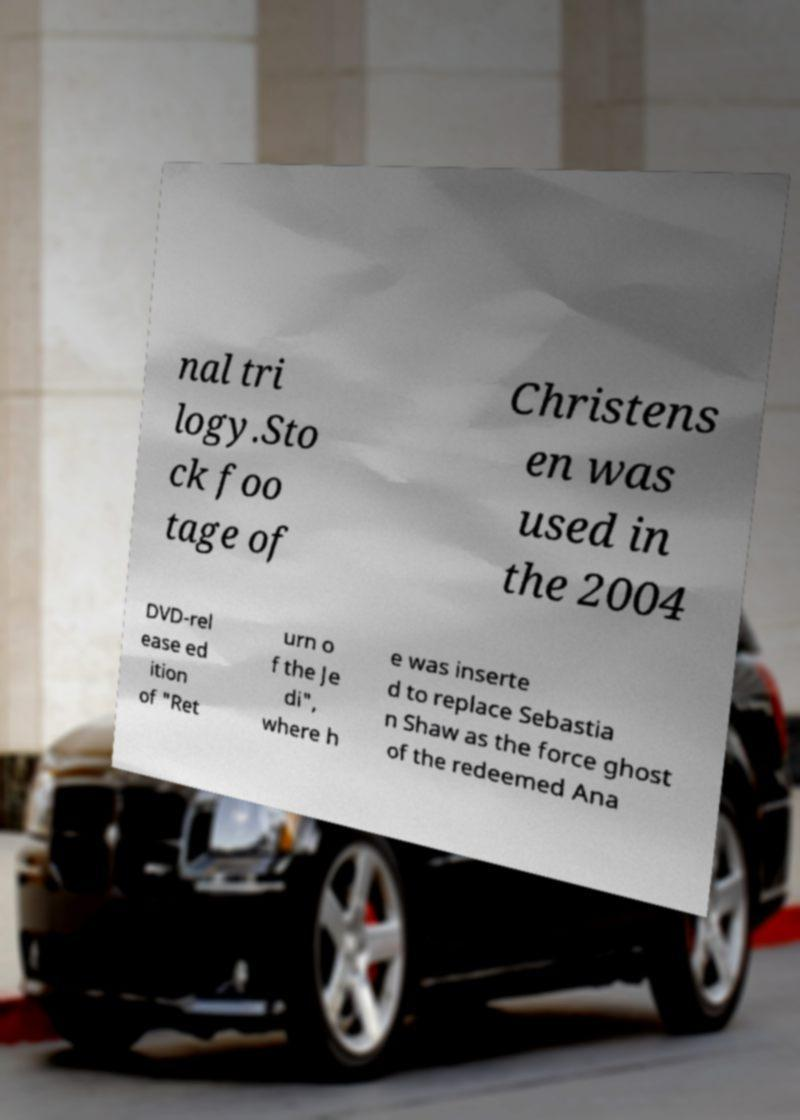Could you extract and type out the text from this image? nal tri logy.Sto ck foo tage of Christens en was used in the 2004 DVD-rel ease ed ition of "Ret urn o f the Je di", where h e was inserte d to replace Sebastia n Shaw as the force ghost of the redeemed Ana 